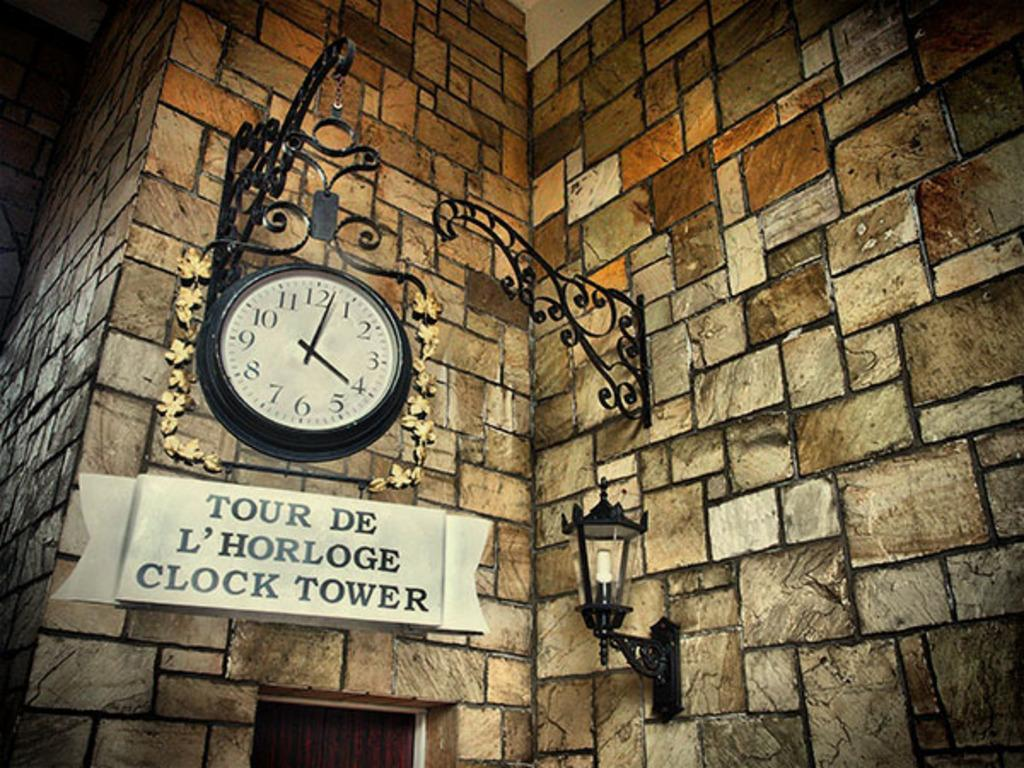<image>
Provide a brief description of the given image. A clock with a sign underneath reading Tour De L'Horloge Clock Tower 